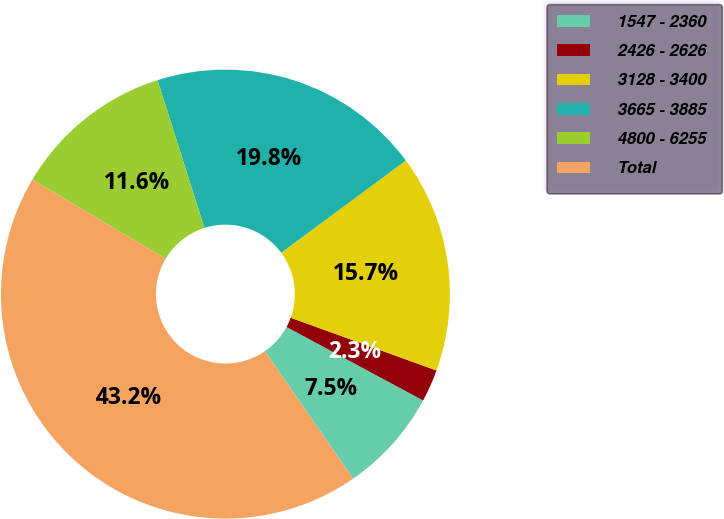Convert chart to OTSL. <chart><loc_0><loc_0><loc_500><loc_500><pie_chart><fcel>1547 - 2360<fcel>2426 - 2626<fcel>3128 - 3400<fcel>3665 - 3885<fcel>4800 - 6255<fcel>Total<nl><fcel>7.51%<fcel>2.33%<fcel>15.67%<fcel>19.75%<fcel>11.59%<fcel>43.15%<nl></chart> 